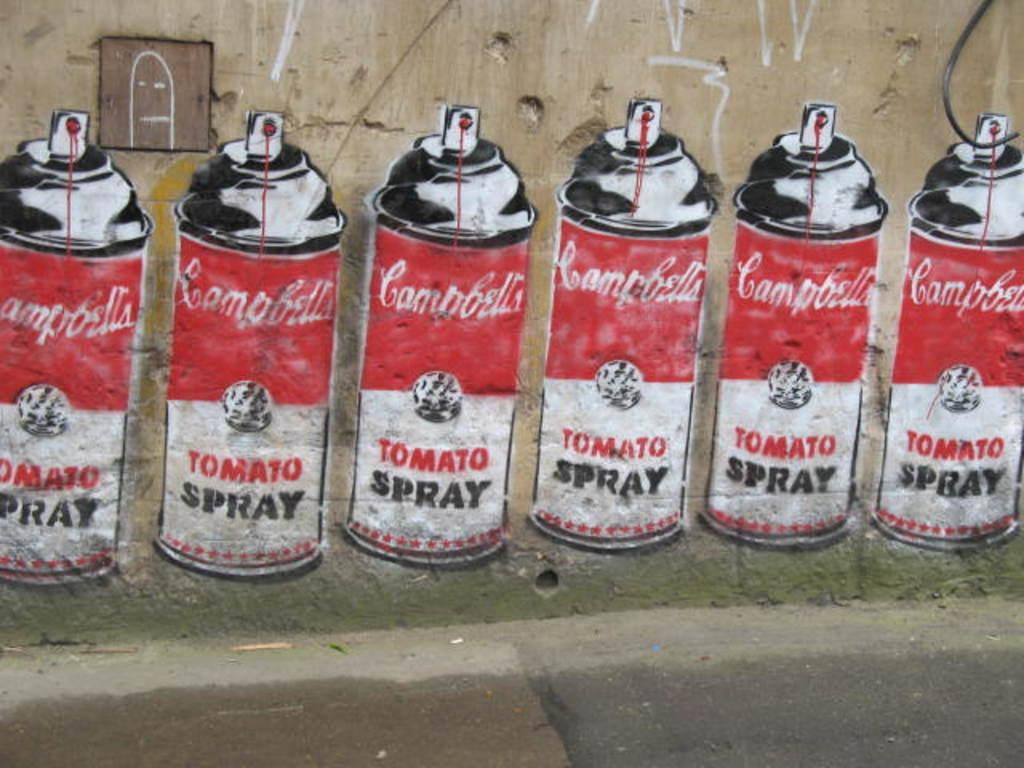<image>
Create a compact narrative representing the image presented. Six paint cans with Campbell's Tomato Spray labels are lined up in a row, with red liquid dripping from the nozzle, in a drawing. 